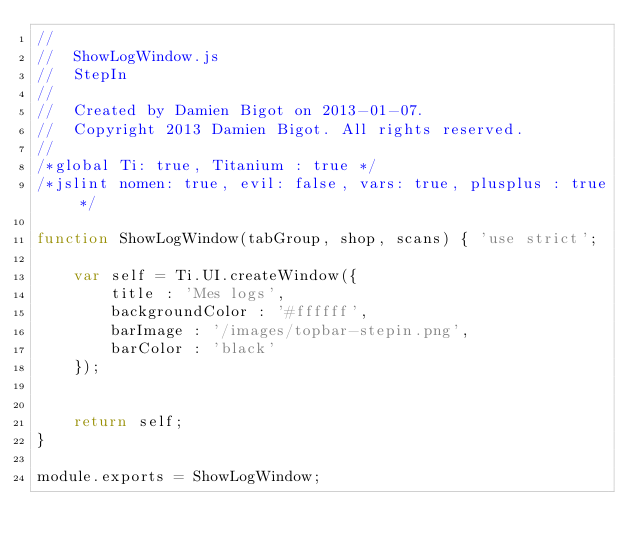Convert code to text. <code><loc_0><loc_0><loc_500><loc_500><_JavaScript_>// 
//  ShowLogWindow.js
//  StepIn
//  
//  Created by Damien Bigot on 2013-01-07.
//  Copyright 2013 Damien Bigot. All rights reserved.
// 
/*global Ti: true, Titanium : true */
/*jslint nomen: true, evil: false, vars: true, plusplus : true */

function ShowLogWindow(tabGroup, shop, scans) { 'use strict';
        
    var self = Ti.UI.createWindow({ 
        title : 'Mes logs', 
        backgroundColor : '#ffffff',
        barImage : '/images/topbar-stepin.png',
        barColor : 'black'
    });
    
    
    return self;
}

module.exports = ShowLogWindow;</code> 